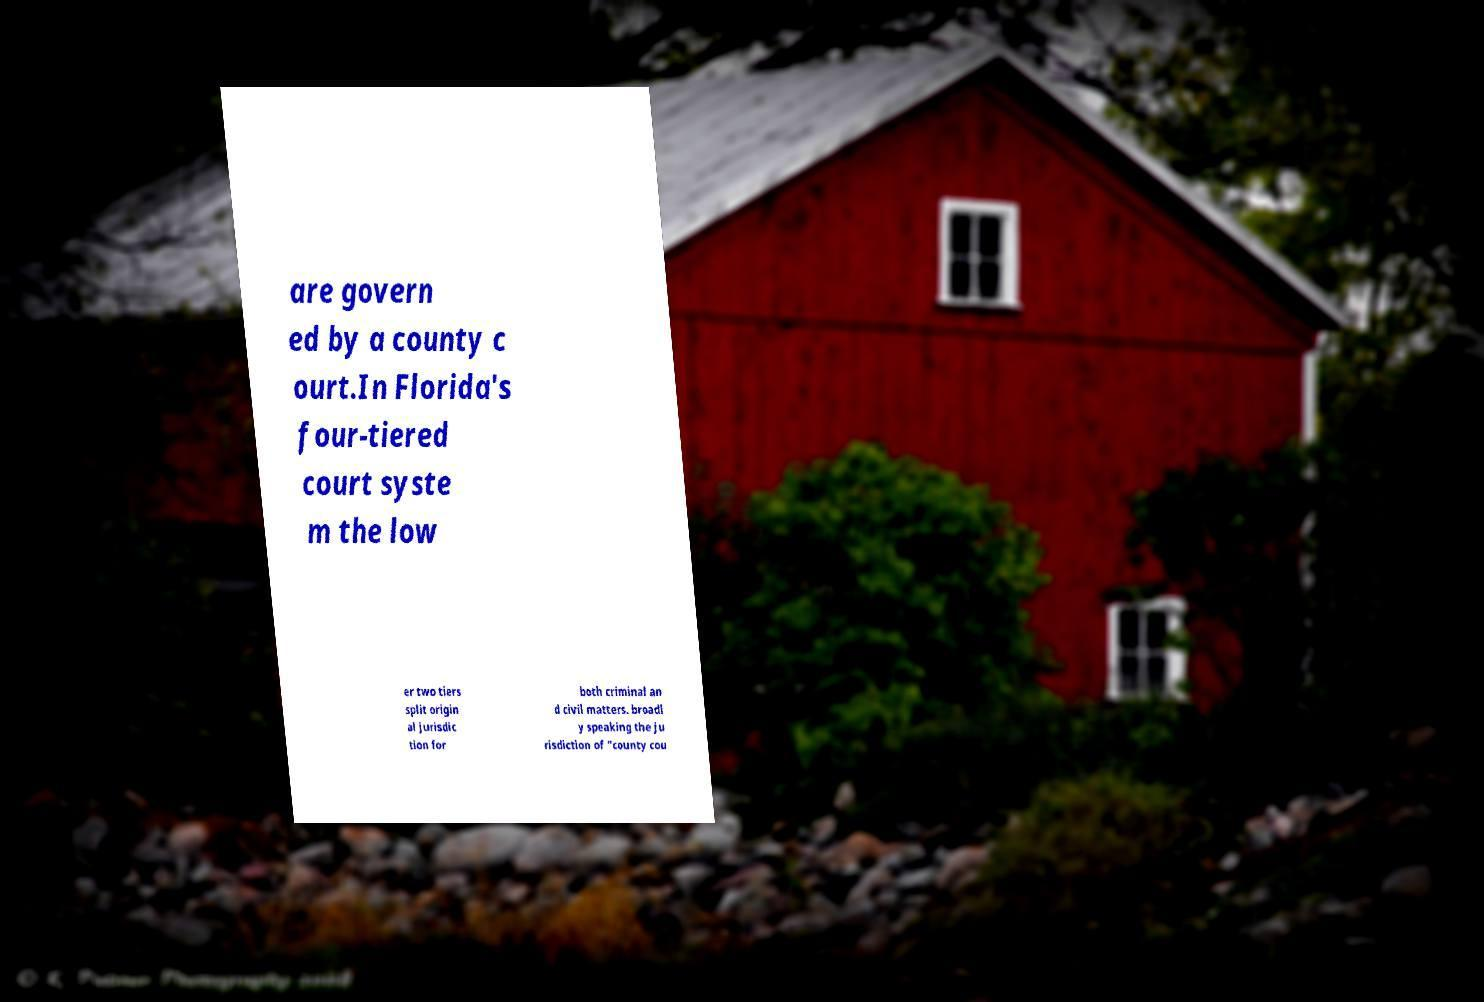Can you accurately transcribe the text from the provided image for me? are govern ed by a county c ourt.In Florida's four-tiered court syste m the low er two tiers split origin al jurisdic tion for both criminal an d civil matters. broadl y speaking the ju risdiction of "county cou 